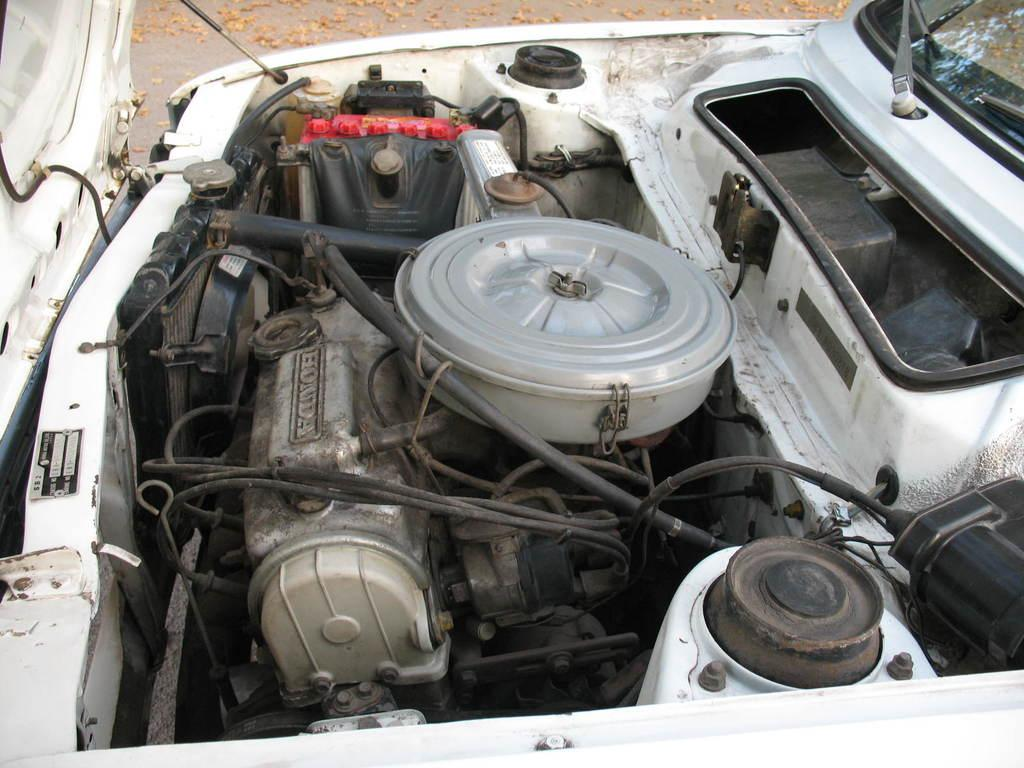What is the main focus of the image? The main focus of the image is the inside parts of a car's bonnet. Can you describe what is visible in the image? The image shows the engine and other internal components of a car's bonnet. How many yams are being used to fuel the car in the image? There are no yams present in the image; it shows the internal components of a car's bonnet. 